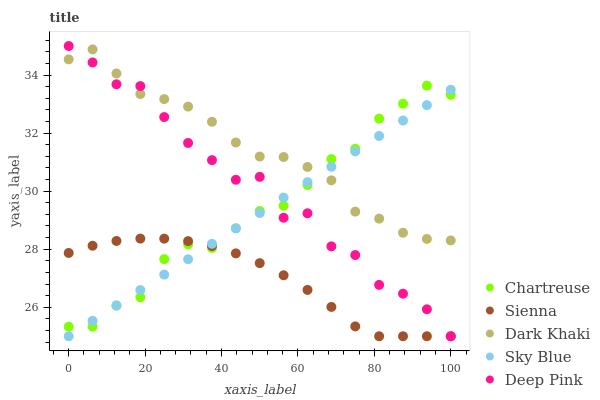Does Sienna have the minimum area under the curve?
Answer yes or no. Yes. Does Dark Khaki have the maximum area under the curve?
Answer yes or no. Yes. Does Chartreuse have the minimum area under the curve?
Answer yes or no. No. Does Chartreuse have the maximum area under the curve?
Answer yes or no. No. Is Sky Blue the smoothest?
Answer yes or no. Yes. Is Deep Pink the roughest?
Answer yes or no. Yes. Is Dark Khaki the smoothest?
Answer yes or no. No. Is Dark Khaki the roughest?
Answer yes or no. No. Does Sienna have the lowest value?
Answer yes or no. Yes. Does Chartreuse have the lowest value?
Answer yes or no. No. Does Deep Pink have the highest value?
Answer yes or no. Yes. Does Dark Khaki have the highest value?
Answer yes or no. No. Is Sienna less than Dark Khaki?
Answer yes or no. Yes. Is Dark Khaki greater than Sienna?
Answer yes or no. Yes. Does Chartreuse intersect Deep Pink?
Answer yes or no. Yes. Is Chartreuse less than Deep Pink?
Answer yes or no. No. Is Chartreuse greater than Deep Pink?
Answer yes or no. No. Does Sienna intersect Dark Khaki?
Answer yes or no. No. 